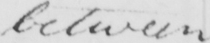Can you read and transcribe this handwriting? between 